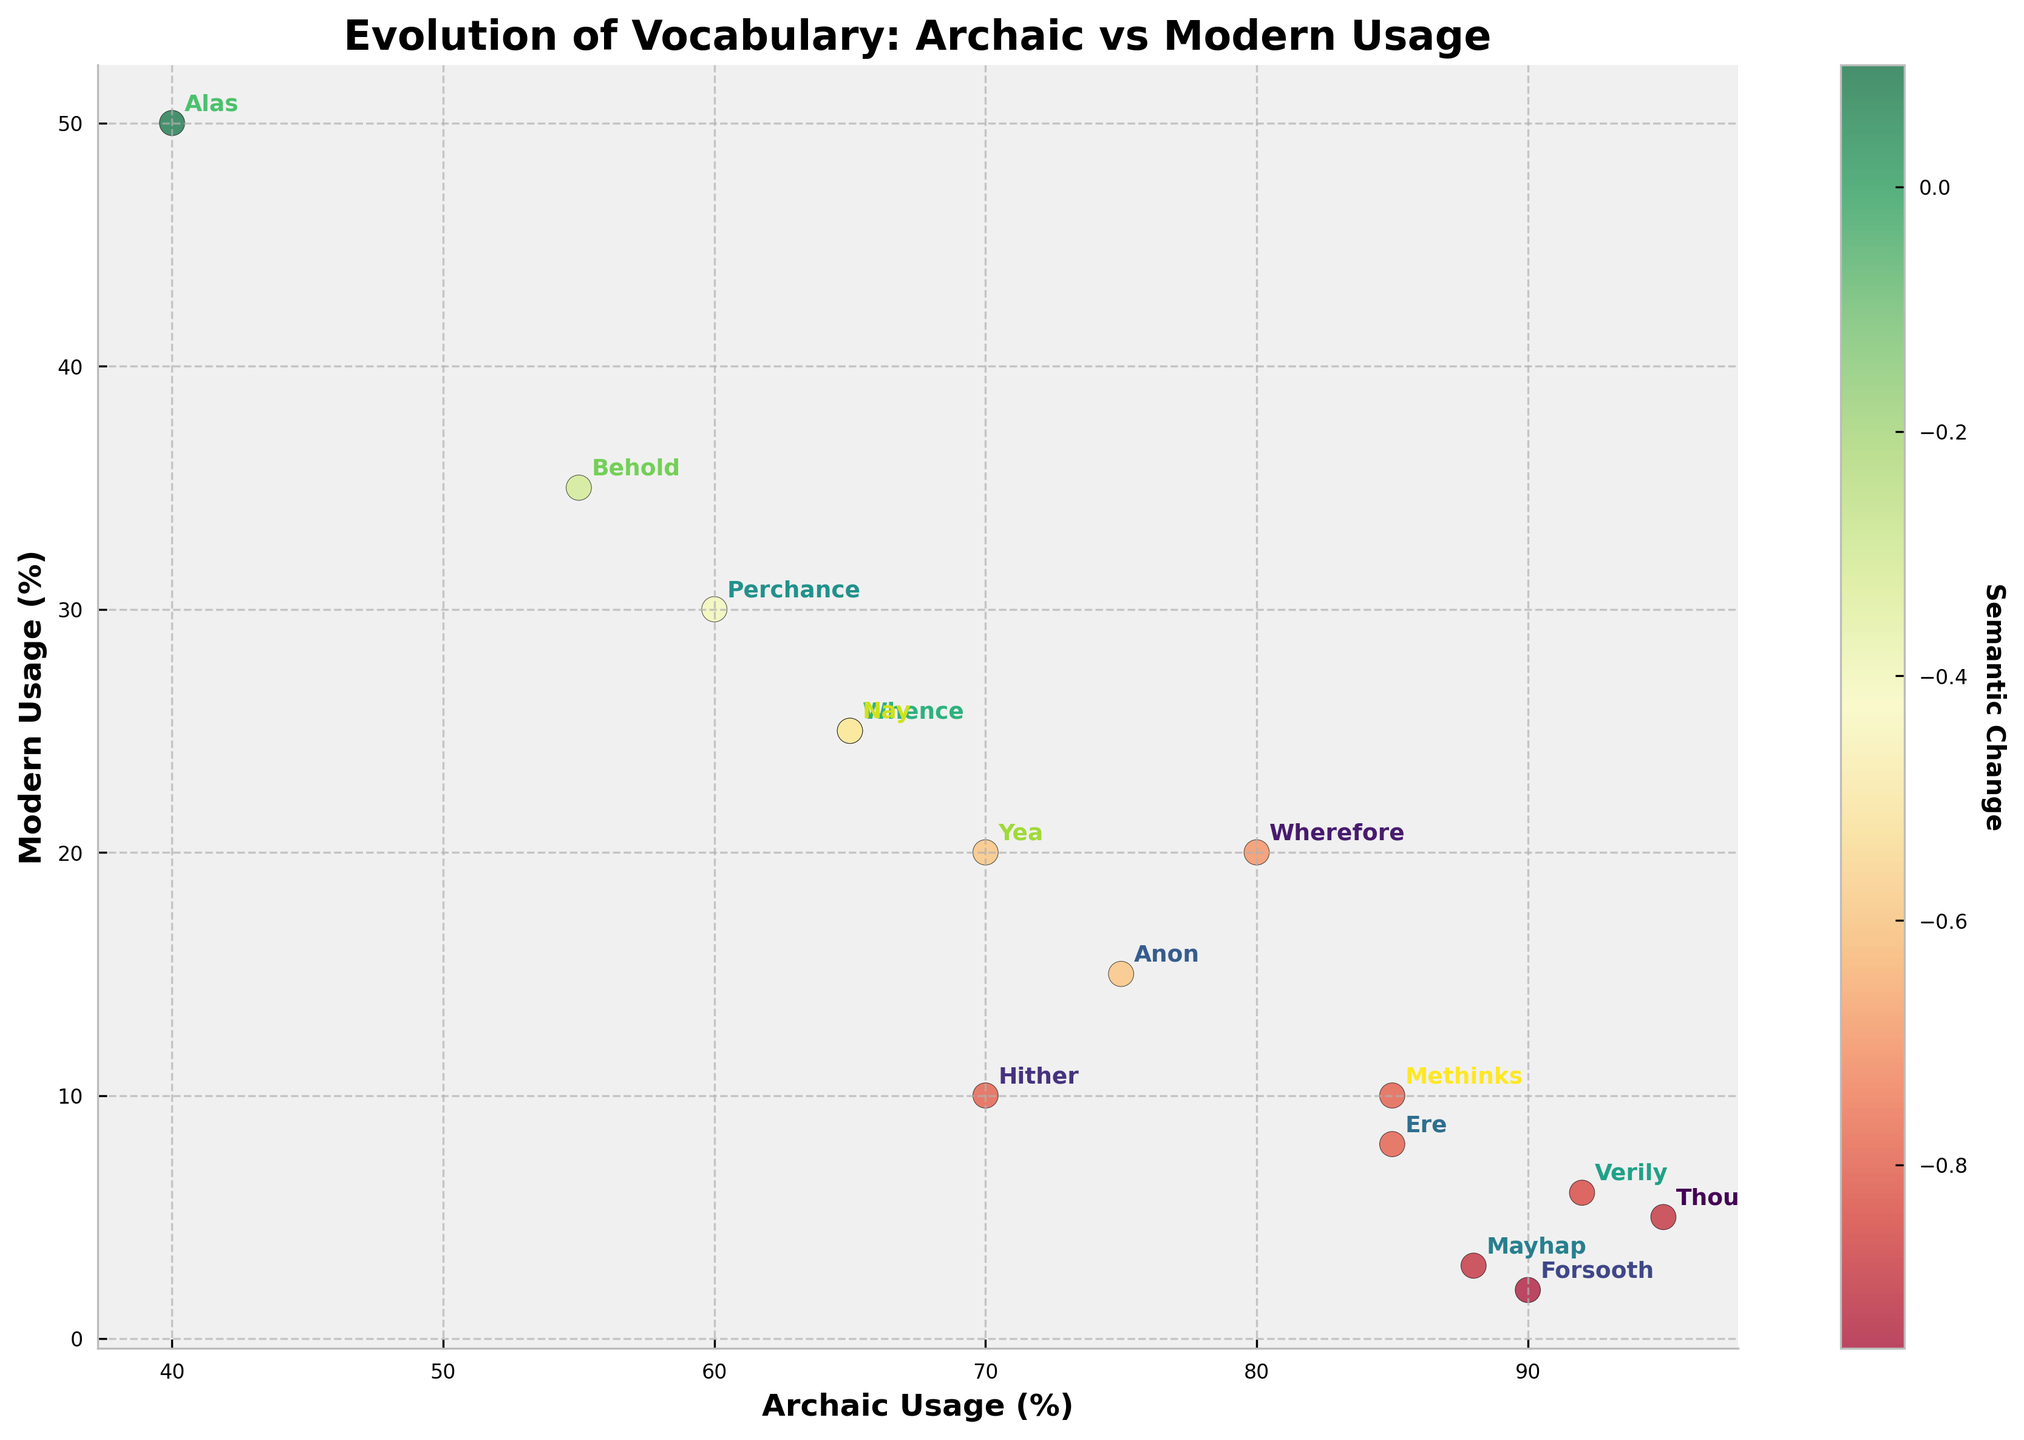What is the title of the biplot? The title is located at the top of the figure, prominently displayed in bold. It summarizes the purpose of the plot—comparing archaic and modern word usage.
Answer: Evolution of Vocabulary: Archaic vs Modern Usage How many data points are plotted in the biplot? Count the number of distinct words annotated on the plot. Each word represents a data point.
Answer: 15 Which word has the highest percentage of archaic usage? Look along the x-axis to find the word with the highest value.
Answer: Thou What is the modern usage percentage of the word "Verily"? Find "Verily" in the plot, and then check its position along the y-axis.
Answer: 6 Which word shows the smallest semantic change? Semantic change is represented by the color intensity, indicated by the color bar. Find the word with the color closest to green (smallest negative change).
Answer: Alas Compare the archaic usage of "Hither" and "Mayhap." Which one is higher? Find "Hither" and "Mayhap" in the plot and compare their positions along the x-axis.
Answer: Hither Calculate the average modern usage percentage of "Anon," "Behold," and "Nay." Identify the y-values for "Anon" (15), "Behold" (35), and "Nay" (25), then compute the average: (15 + 35 + 25) / 3.
Answer: 25 What is the sum of the archaic usage percentages for "Yea" and "Methinks"? Identify the x-values for "Yea" (70) and "Methinks" (85), and then sum them up: 70 + 85.
Answer: 155 Which word has a higher modern usage percentage, "Perchance" or "Whence"? Compare the y-values of "Perchance" (30) and "Whence" (25).
Answer: Perchance Find the difference in archaic usage percentage between "Forsooth" and "Whence." Identify x-values for "Forsooth" (90) and "Whence" (65), then subtract the latter from the former: 90 - 65.
Answer: 25 